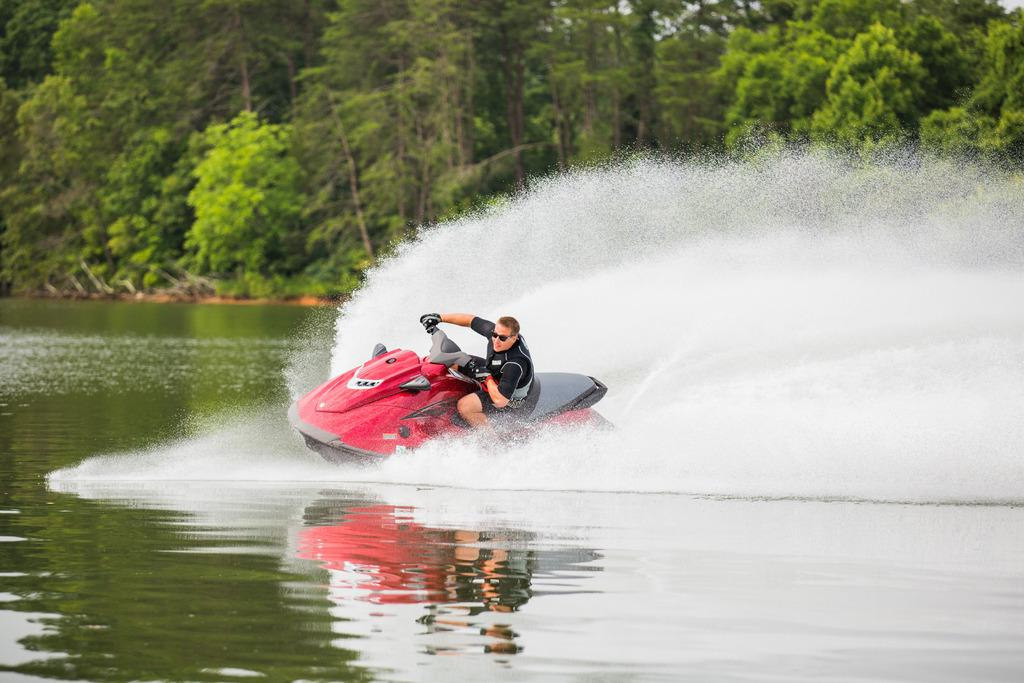Who is the main subject in the image? There is a man in the image. What is the man doing in the image? The man is riding a jet ski. What type of environment is depicted in the image? There is water at the bottom of the image, suggesting a water-based setting. What can be seen in the background of the image? There are trees in the background of the image. What type of basin is visible in the image? There is no basin present in the image. Is the man in the image experiencing any trouble while riding the jet ski? The image does not provide any information about the man's experience or any potential trouble he might be facing. 